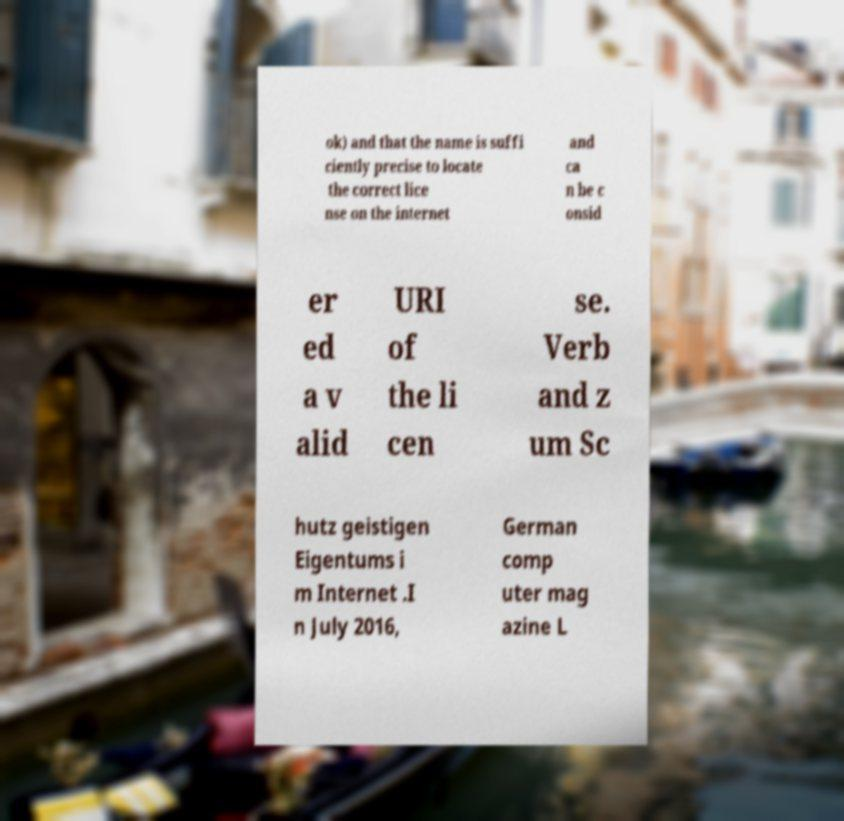I need the written content from this picture converted into text. Can you do that? ok) and that the name is suffi ciently precise to locate the correct lice nse on the internet and ca n be c onsid er ed a v alid URI of the li cen se. Verb and z um Sc hutz geistigen Eigentums i m Internet .I n July 2016, German comp uter mag azine L 